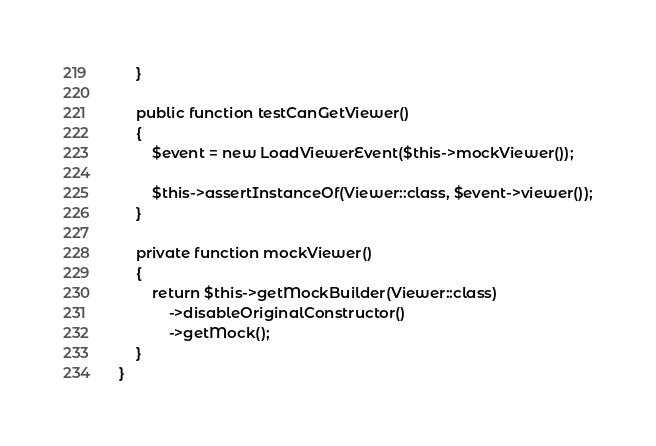<code> <loc_0><loc_0><loc_500><loc_500><_PHP_>    }

    public function testCanGetViewer()
    {
        $event = new LoadViewerEvent($this->mockViewer());

        $this->assertInstanceOf(Viewer::class, $event->viewer());
    }

    private function mockViewer()
    {
        return $this->getMockBuilder(Viewer::class)
            ->disableOriginalConstructor()
            ->getMock();
    }
}
</code> 